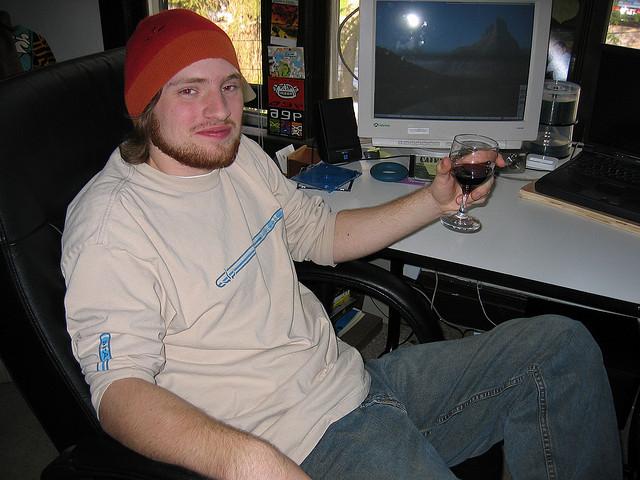What is the guy holding in his left hand?
Write a very short answer. Wine glass. Is the desk messy?
Concise answer only. Yes. How many people are wearing blue jeans in this photo?
Be succinct. 1. What is the man doing?
Short answer required. Drinking wine. Is he drinking tea or coffee?
Answer briefly. No. Is he fixing something?
Quick response, please. No. What is the man sitting on?
Answer briefly. Chair. What is the man holding in his left hand?
Short answer required. Wine glass. What does his shirt say?
Give a very brief answer. Nothing. What color is the man's hat?
Give a very brief answer. Red. What is he doing?
Answer briefly. Drinking wine. What is the color of the chair the boy is sitting in?
Be succinct. Black. What is the man holding?
Keep it brief. Wine glass. Does the man have a surround sound system?
Write a very short answer. No. What color are his eyes?
Keep it brief. Brown. Does this man have long hair?
Give a very brief answer. Yes. Does the guy have facial hair?
Answer briefly. Yes. What video game system is this?
Quick response, please. Computer. What is on this persons head?
Be succinct. Hat. Is this man carrying luggage?
Keep it brief. No. How many caps in the picture?
Short answer required. 1. 